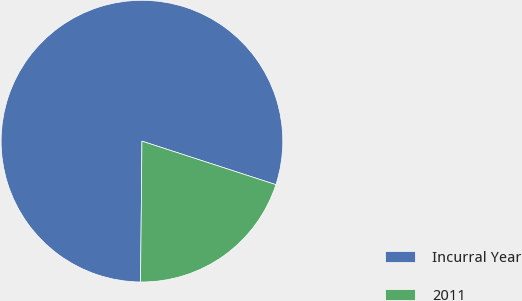Convert chart. <chart><loc_0><loc_0><loc_500><loc_500><pie_chart><fcel>Incurral Year<fcel>2011<nl><fcel>79.84%<fcel>20.16%<nl></chart> 